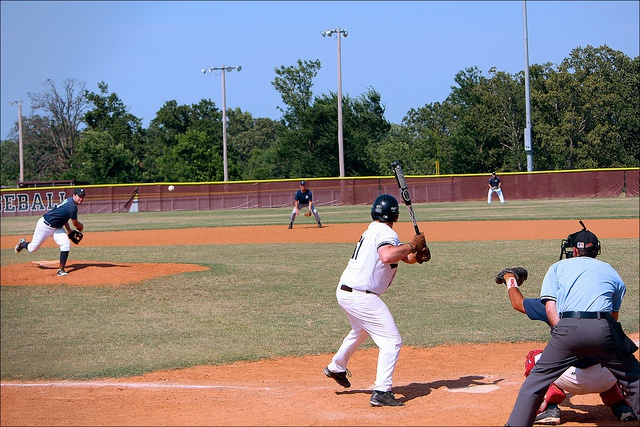Describe the objects in this image and their specific colors. I can see people in black, gray, and lightblue tones, people in black, lavender, darkgray, and brown tones, people in black, gray, maroon, and navy tones, people in black, lavender, navy, and maroon tones, and people in black, gray, navy, and brown tones in this image. 